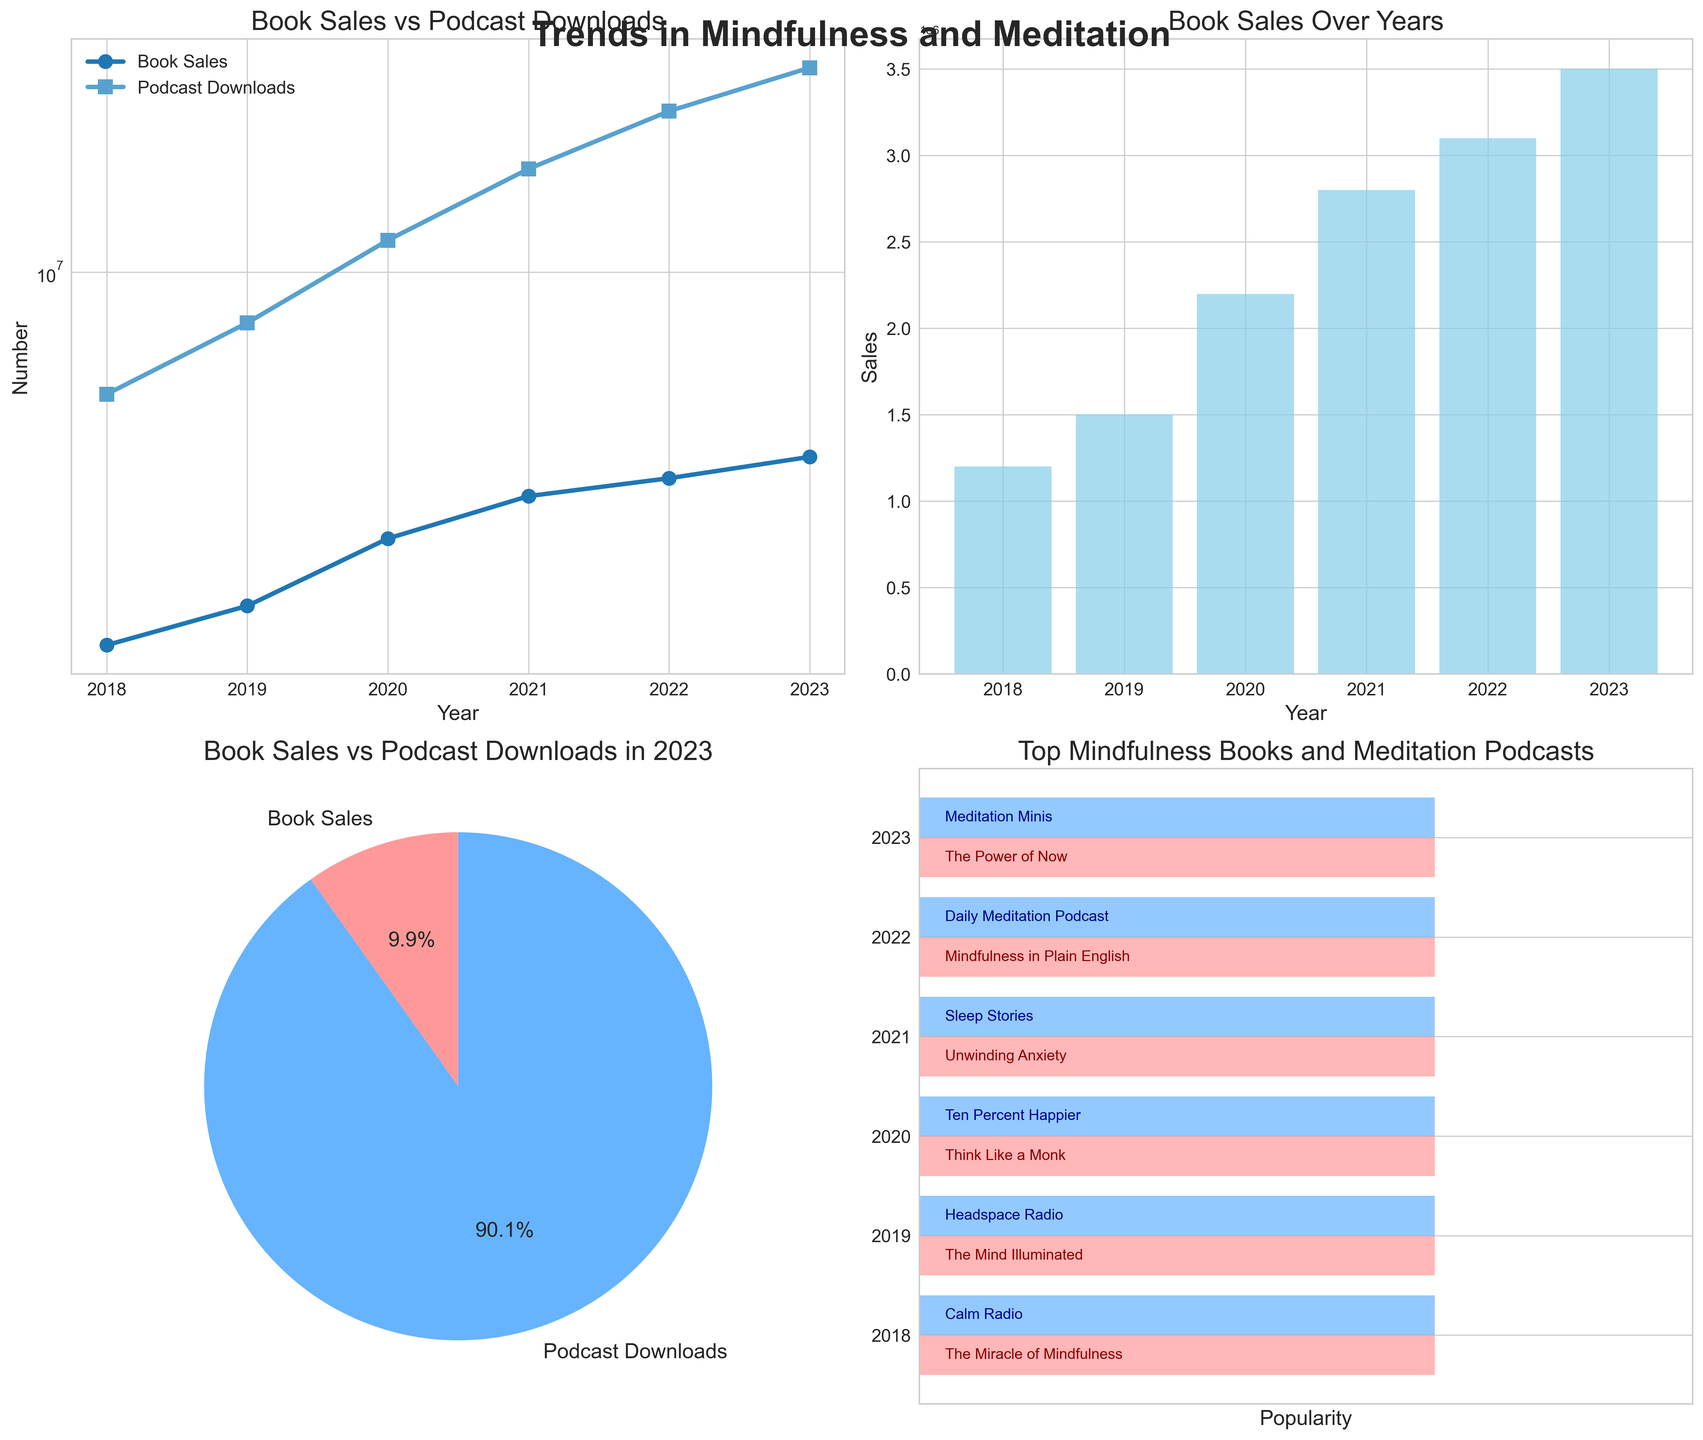what is the title of the line plot in the top-left subplot? Look at the top of the line plot in the top-left. The title is displayed there. It reads "Book Sales vs Podcast Downloads".
Answer: Book Sales vs Podcast Downloads How many years are displayed in the bar plot for book sales? Count the number of bars present in the bar plot. Each bar represents a year. There are 6 bars for 6 years from 2018 to 2023.
Answer: 6 What percentage of the latest year's data are podcast downloads according to the pie chart? In the pie chart for the latest year (2023), look at the segment labeled "Podcast Downloads" and note the percentage. The segment for Podcast Downloads shows 90.1%.
Answer: 90.1% Which year saw the highest book sales? In the top-left line plot, observe the data points for "Book Sales" and find the highest one. Similarly, confirm it in the bar plot. The highest book sales are in the year 2023 at 3,500,000.
Answer: 2023 Compare the values of book sales and podcast downloads in 2020. Which is greater and by how much? In the line plots for 2020, note the values: Book Sales = 2,200,000 and Podcast Downloads = 12,000,000. Subtract Book Sales from Podcast Downloads to find the difference. The difference is 12,000,000 - 2,200,000 = 9,800,000. Podcast downloads are greater by 9,800,000.
Answer: Podcast downloads by 9,800,000 What is the top meditation podcast in 2022? In the horizontal bar chart at the bottom-right, look for the row labeled "2022". The text inside the blue bar will provide the name of the podcast. The top meditation podcast in 2022 is "Daily Meditation Podcast".
Answer: Daily Meditation Podcast What trend can be observed in the book sales over the years from 2018 to 2023? Look at the trend line in the line plot and the bars in the bar plot for book sales. The number of book sales has been increasing every year from 2018 to 2023.
Answer: Increasing How does the pie chart represent the proportion of book sales to podcast downloads in 2023? The pie chart shows two segments: Book Sales and Podcast Downloads for 2023. The podcast downloads segment takes up a significantly larger portion (90.1%) compared to book sales (9.9%).
Answer: 9.9% (Book Sales) and 90.1% (Podcast Downloads) 